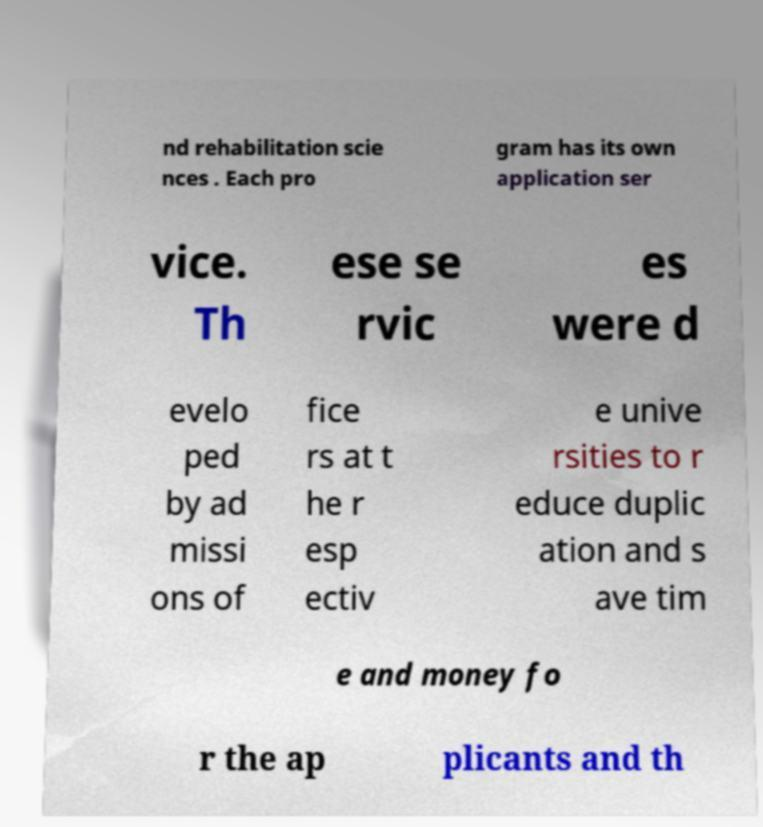For documentation purposes, I need the text within this image transcribed. Could you provide that? nd rehabilitation scie nces . Each pro gram has its own application ser vice. Th ese se rvic es were d evelo ped by ad missi ons of fice rs at t he r esp ectiv e unive rsities to r educe duplic ation and s ave tim e and money fo r the ap plicants and th 